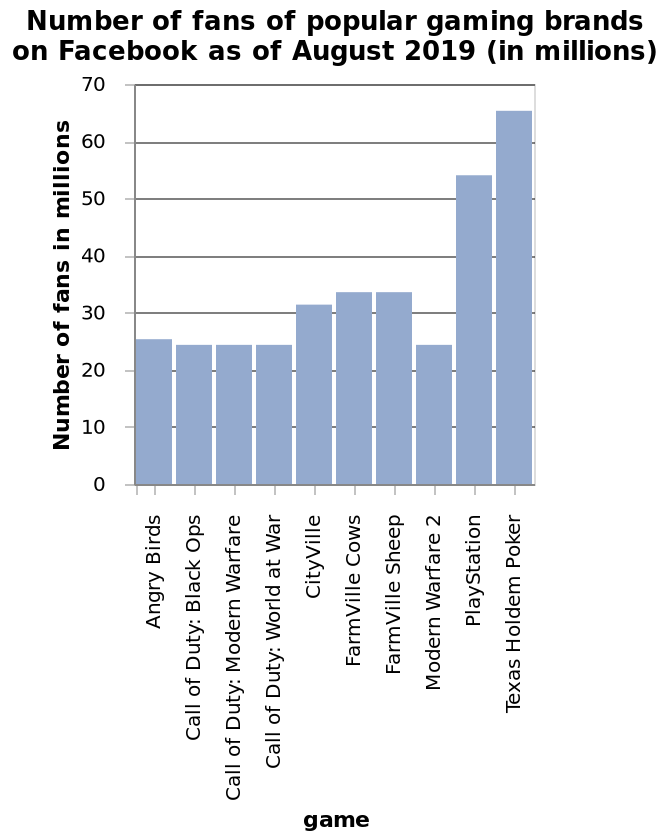<image>
What is the time period for which the number of fans is recorded in this bar plot? The number of fans is recorded as of August 2019. What is the range of the y-axis scale in this bar plot? The range of the y-axis scale is from 0 to 70, representing the number of fans in millions. 